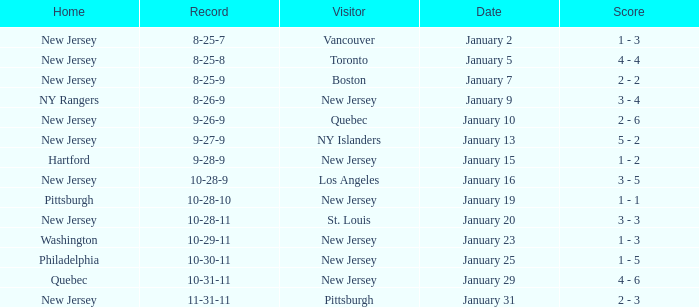What was the home team when the visiting team was Toronto? New Jersey. 